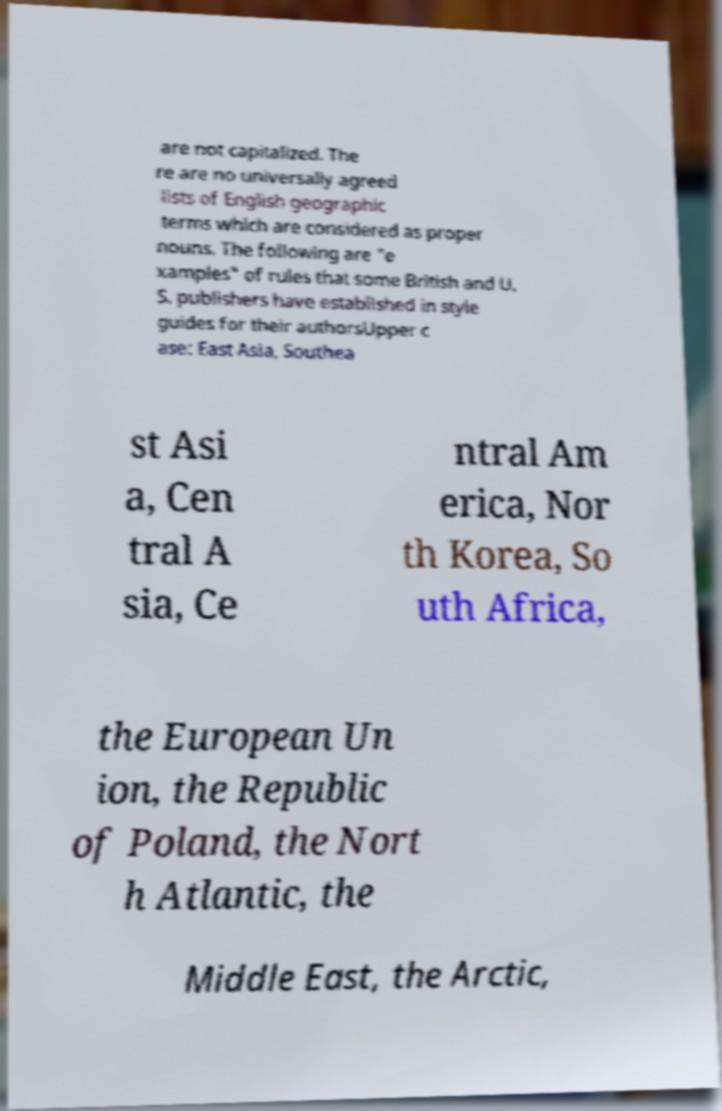There's text embedded in this image that I need extracted. Can you transcribe it verbatim? are not capitalized. The re are no universally agreed lists of English geographic terms which are considered as proper nouns. The following are "e xamples" of rules that some British and U. S. publishers have established in style guides for their authorsUpper c ase: East Asia, Southea st Asi a, Cen tral A sia, Ce ntral Am erica, Nor th Korea, So uth Africa, the European Un ion, the Republic of Poland, the Nort h Atlantic, the Middle East, the Arctic, 